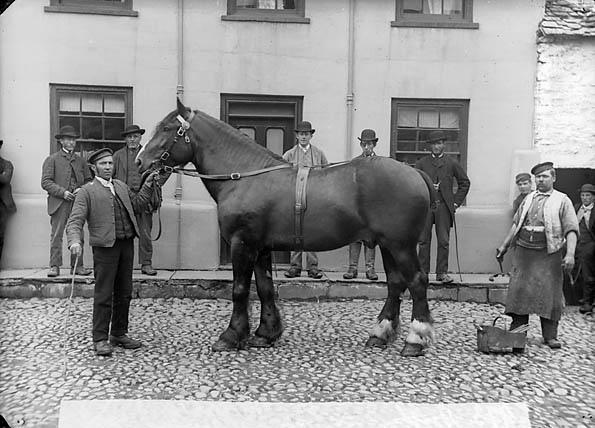How many men are standing up?
Give a very brief answer. 10. How many people can you see?
Give a very brief answer. 4. How many cats are in this picture?
Give a very brief answer. 0. 